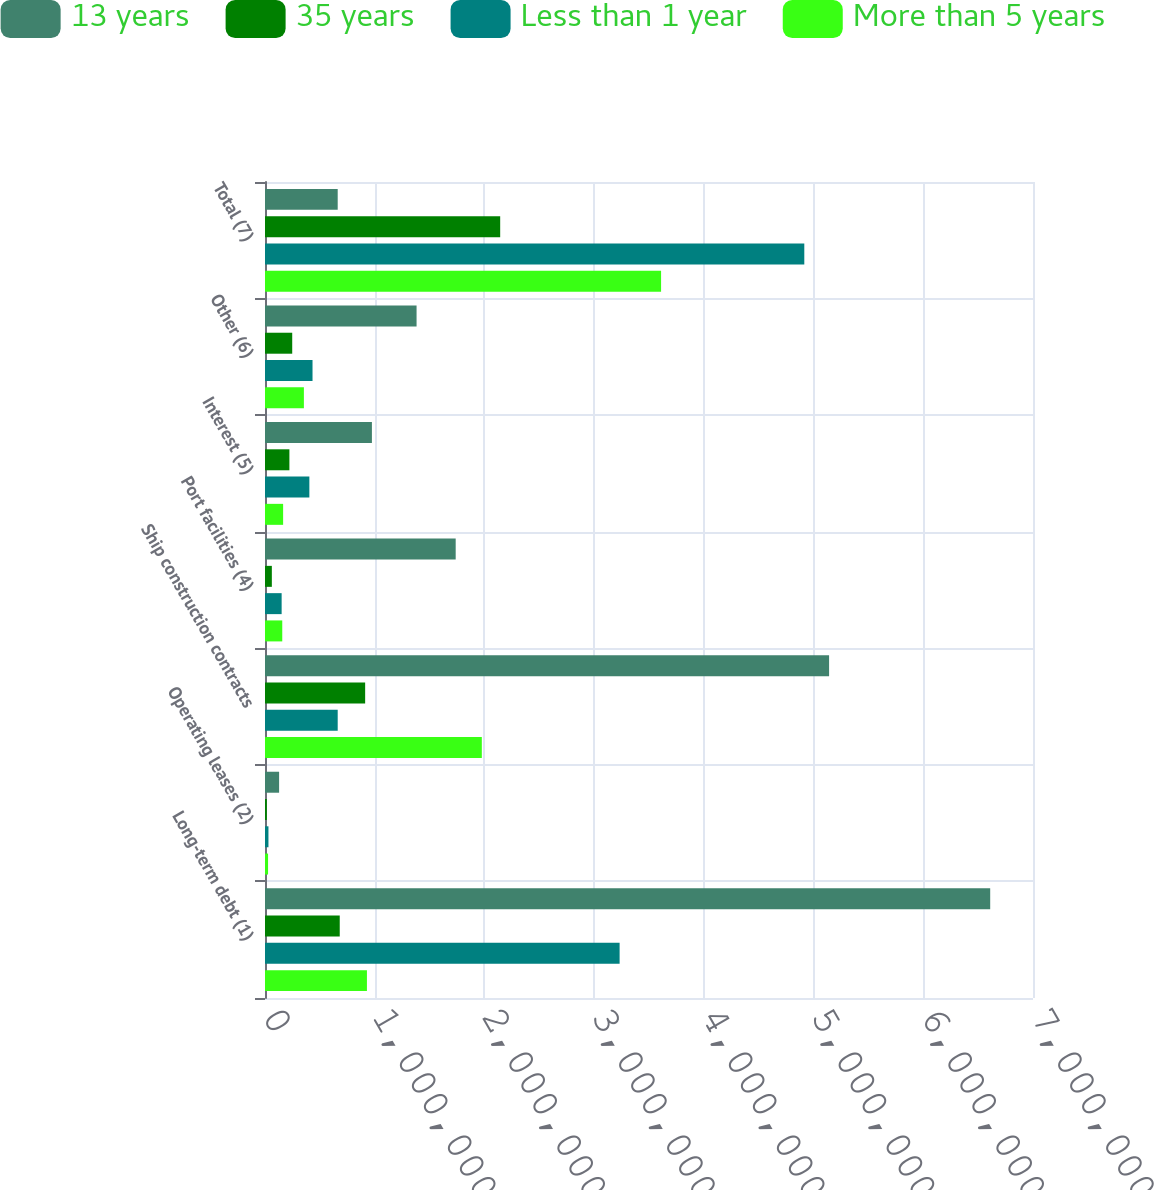<chart> <loc_0><loc_0><loc_500><loc_500><stacked_bar_chart><ecel><fcel>Long-term debt (1)<fcel>Operating leases (2)<fcel>Ship construction contracts<fcel>Port facilities (4)<fcel>Interest (5)<fcel>Other (6)<fcel>Total (7)<nl><fcel>13 years<fcel>6.60987e+06<fcel>128550<fcel>5.14144e+06<fcel>1.73804e+06<fcel>974444<fcel>1.38152e+06<fcel>662687<nl><fcel>35 years<fcel>681218<fcel>16651<fcel>912858<fcel>62388<fcel>222427<fcel>248107<fcel>2.14365e+06<nl><fcel>Less than 1 year<fcel>3.23218e+06<fcel>31420<fcel>662687<fcel>151682<fcel>404380<fcel>433161<fcel>4.91551e+06<nl><fcel>More than 5 years<fcel>929088<fcel>27853<fcel>1.97622e+06<fcel>157330<fcel>165172<fcel>354454<fcel>3.61012e+06<nl></chart> 